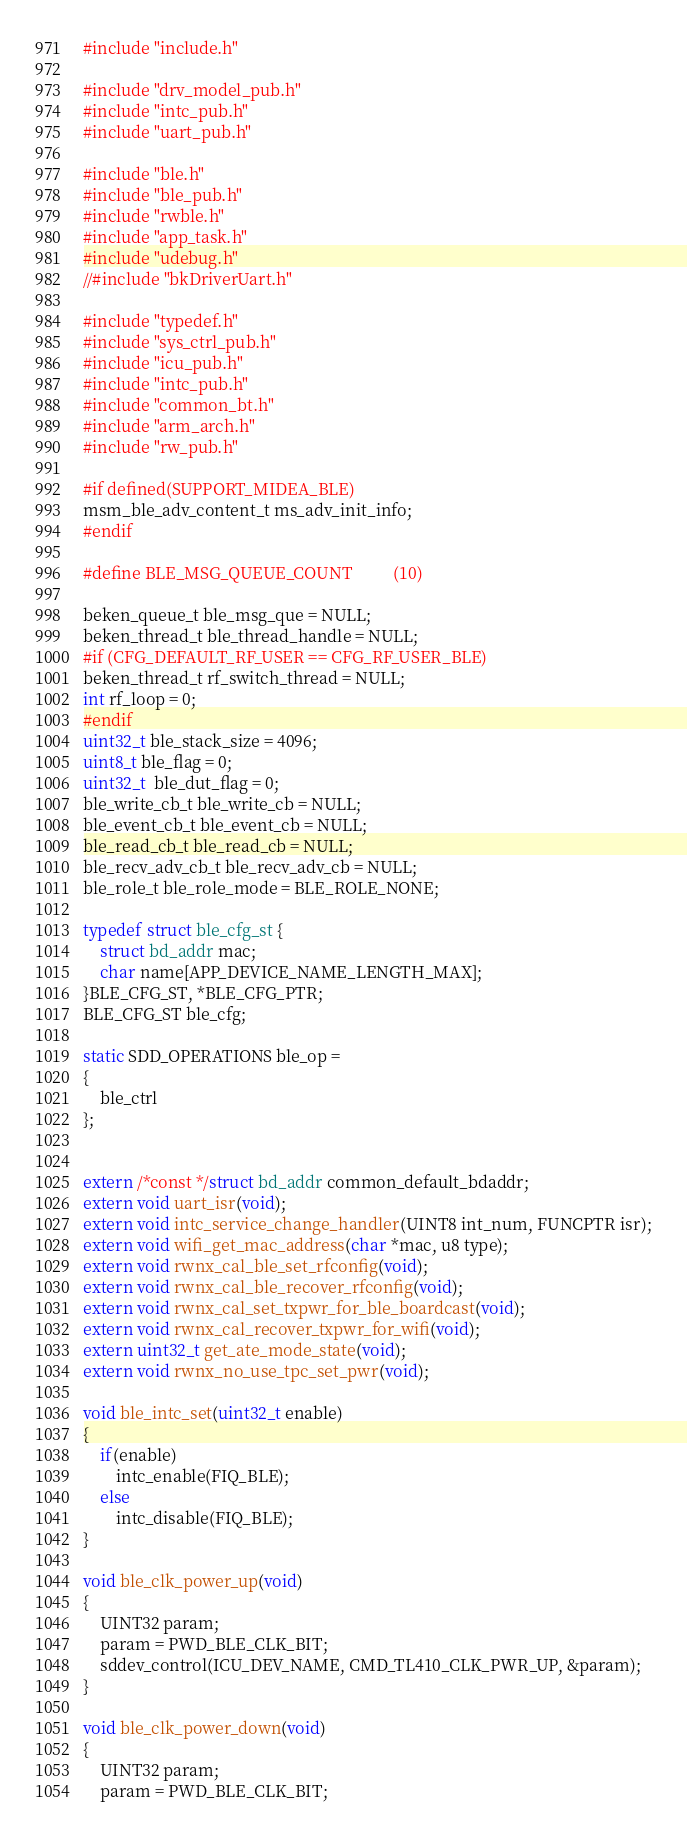<code> <loc_0><loc_0><loc_500><loc_500><_C_>#include "include.h"

#include "drv_model_pub.h"
#include "intc_pub.h"
#include "uart_pub.h"

#include "ble.h"
#include "ble_pub.h"
#include "rwble.h"
#include "app_task.h"
#include "udebug.h"
//#include "bkDriverUart.h"

#include "typedef.h"
#include "sys_ctrl_pub.h"
#include "icu_pub.h"
#include "intc_pub.h"
#include "common_bt.h"
#include "arm_arch.h"
#include "rw_pub.h"

#if defined(SUPPORT_MIDEA_BLE)
msm_ble_adv_content_t ms_adv_init_info;
#endif

#define BLE_MSG_QUEUE_COUNT          (10)

beken_queue_t ble_msg_que = NULL;
beken_thread_t ble_thread_handle = NULL;
#if (CFG_DEFAULT_RF_USER == CFG_RF_USER_BLE)
beken_thread_t rf_switch_thread = NULL;
int rf_loop = 0;
#endif
uint32_t ble_stack_size = 4096;
uint8_t ble_flag = 0;
uint32_t  ble_dut_flag = 0;
ble_write_cb_t ble_write_cb = NULL;
ble_event_cb_t ble_event_cb = NULL;
ble_read_cb_t ble_read_cb = NULL;
ble_recv_adv_cb_t ble_recv_adv_cb = NULL;
ble_role_t ble_role_mode = BLE_ROLE_NONE;

typedef struct ble_cfg_st {
    struct bd_addr mac;
    char name[APP_DEVICE_NAME_LENGTH_MAX];
}BLE_CFG_ST, *BLE_CFG_PTR; 
BLE_CFG_ST ble_cfg;

static SDD_OPERATIONS ble_op =
{
    ble_ctrl
};


extern /*const */struct bd_addr common_default_bdaddr;
extern void uart_isr(void);
extern void intc_service_change_handler(UINT8 int_num, FUNCPTR isr);
extern void wifi_get_mac_address(char *mac, u8 type);
extern void rwnx_cal_ble_set_rfconfig(void);
extern void rwnx_cal_ble_recover_rfconfig(void);
extern void rwnx_cal_set_txpwr_for_ble_boardcast(void);
extern void rwnx_cal_recover_txpwr_for_wifi(void);
extern uint32_t get_ate_mode_state(void);
extern void rwnx_no_use_tpc_set_pwr(void);

void ble_intc_set(uint32_t enable)
{
    if(enable)
        intc_enable(FIQ_BLE);
    else
        intc_disable(FIQ_BLE);
}

void ble_clk_power_up(void)
{
    UINT32 param;
    param = PWD_BLE_CLK_BIT;
    sddev_control(ICU_DEV_NAME, CMD_TL410_CLK_PWR_UP, &param);
}

void ble_clk_power_down(void)
{
    UINT32 param;
    param = PWD_BLE_CLK_BIT;</code> 